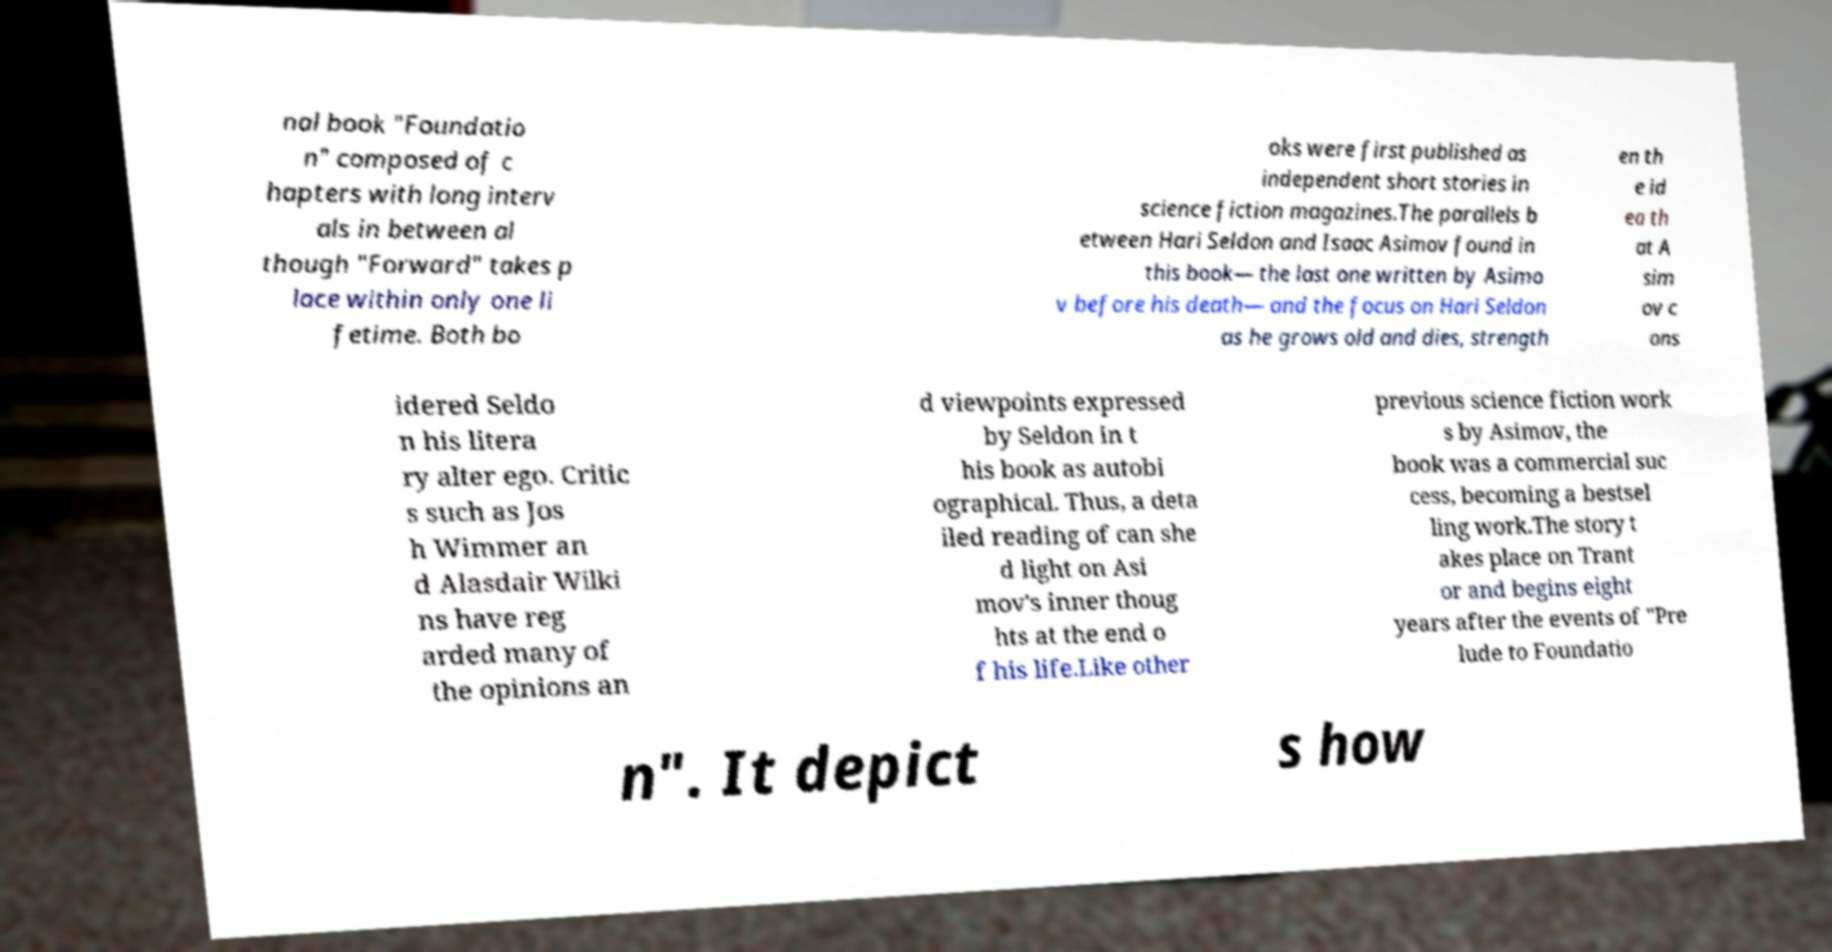I need the written content from this picture converted into text. Can you do that? nal book "Foundatio n" composed of c hapters with long interv als in between al though "Forward" takes p lace within only one li fetime. Both bo oks were first published as independent short stories in science fiction magazines.The parallels b etween Hari Seldon and Isaac Asimov found in this book— the last one written by Asimo v before his death— and the focus on Hari Seldon as he grows old and dies, strength en th e id ea th at A sim ov c ons idered Seldo n his litera ry alter ego. Critic s such as Jos h Wimmer an d Alasdair Wilki ns have reg arded many of the opinions an d viewpoints expressed by Seldon in t his book as autobi ographical. Thus, a deta iled reading of can she d light on Asi mov's inner thoug hts at the end o f his life.Like other previous science fiction work s by Asimov, the book was a commercial suc cess, becoming a bestsel ling work.The story t akes place on Trant or and begins eight years after the events of "Pre lude to Foundatio n". It depict s how 